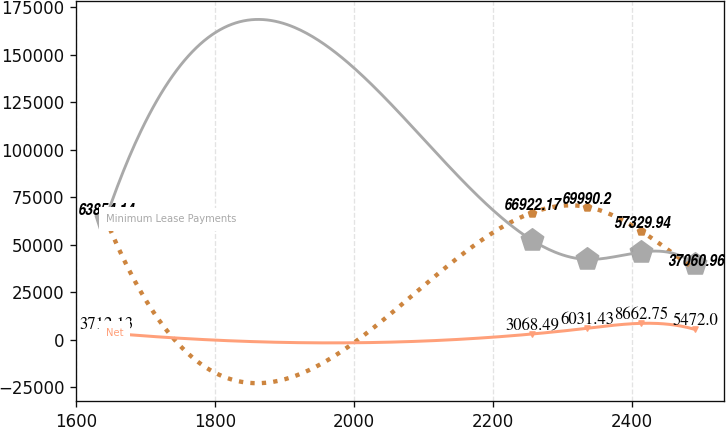Convert chart. <chart><loc_0><loc_0><loc_500><loc_500><line_chart><ecel><fcel>Sublease Income<fcel>Net<fcel>Minimum Lease Payments<nl><fcel>1642.3<fcel>63854.1<fcel>3712.13<fcel>63390.1<nl><fcel>2256.78<fcel>66922.2<fcel>3068.49<fcel>52317.6<nl><fcel>2334.85<fcel>69990.2<fcel>6031.43<fcel>42329<nl><fcel>2412.92<fcel>57329.9<fcel>8662.75<fcel>46139.4<nl><fcel>2490.99<fcel>37061<fcel>5472<fcel>39830.6<nl></chart> 